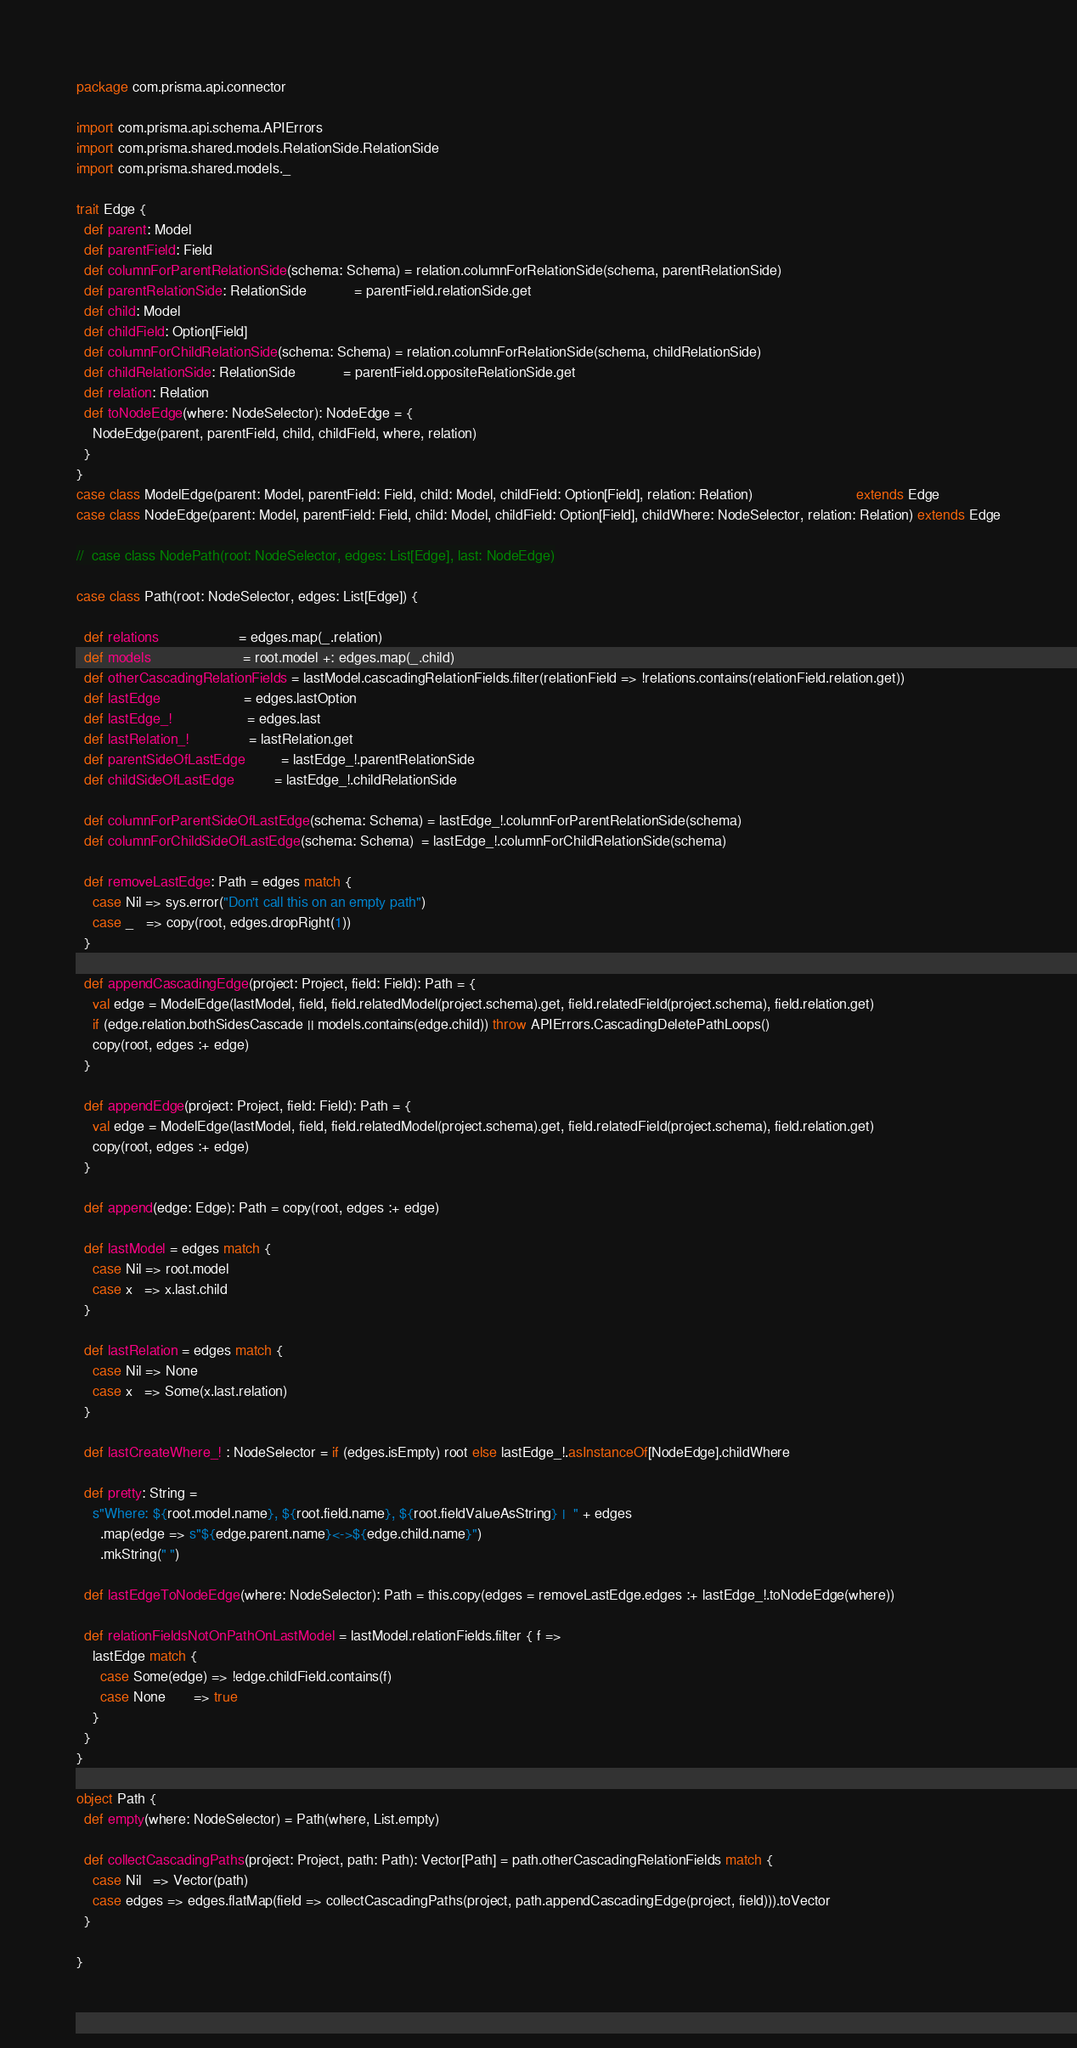Convert code to text. <code><loc_0><loc_0><loc_500><loc_500><_Scala_>package com.prisma.api.connector

import com.prisma.api.schema.APIErrors
import com.prisma.shared.models.RelationSide.RelationSide
import com.prisma.shared.models._

trait Edge {
  def parent: Model
  def parentField: Field
  def columnForParentRelationSide(schema: Schema) = relation.columnForRelationSide(schema, parentRelationSide)
  def parentRelationSide: RelationSide            = parentField.relationSide.get
  def child: Model
  def childField: Option[Field]
  def columnForChildRelationSide(schema: Schema) = relation.columnForRelationSide(schema, childRelationSide)
  def childRelationSide: RelationSide            = parentField.oppositeRelationSide.get
  def relation: Relation
  def toNodeEdge(where: NodeSelector): NodeEdge = {
    NodeEdge(parent, parentField, child, childField, where, relation)
  }
}
case class ModelEdge(parent: Model, parentField: Field, child: Model, childField: Option[Field], relation: Relation)                          extends Edge
case class NodeEdge(parent: Model, parentField: Field, child: Model, childField: Option[Field], childWhere: NodeSelector, relation: Relation) extends Edge

//  case class NodePath(root: NodeSelector, edges: List[Edge], last: NodeEdge)

case class Path(root: NodeSelector, edges: List[Edge]) {

  def relations                    = edges.map(_.relation)
  def models                       = root.model +: edges.map(_.child)
  def otherCascadingRelationFields = lastModel.cascadingRelationFields.filter(relationField => !relations.contains(relationField.relation.get))
  def lastEdge                     = edges.lastOption
  def lastEdge_!                   = edges.last
  def lastRelation_!               = lastRelation.get
  def parentSideOfLastEdge         = lastEdge_!.parentRelationSide
  def childSideOfLastEdge          = lastEdge_!.childRelationSide

  def columnForParentSideOfLastEdge(schema: Schema) = lastEdge_!.columnForParentRelationSide(schema)
  def columnForChildSideOfLastEdge(schema: Schema)  = lastEdge_!.columnForChildRelationSide(schema)

  def removeLastEdge: Path = edges match {
    case Nil => sys.error("Don't call this on an empty path")
    case _   => copy(root, edges.dropRight(1))
  }

  def appendCascadingEdge(project: Project, field: Field): Path = {
    val edge = ModelEdge(lastModel, field, field.relatedModel(project.schema).get, field.relatedField(project.schema), field.relation.get)
    if (edge.relation.bothSidesCascade || models.contains(edge.child)) throw APIErrors.CascadingDeletePathLoops()
    copy(root, edges :+ edge)
  }

  def appendEdge(project: Project, field: Field): Path = {
    val edge = ModelEdge(lastModel, field, field.relatedModel(project.schema).get, field.relatedField(project.schema), field.relation.get)
    copy(root, edges :+ edge)
  }

  def append(edge: Edge): Path = copy(root, edges :+ edge)

  def lastModel = edges match {
    case Nil => root.model
    case x   => x.last.child
  }

  def lastRelation = edges match {
    case Nil => None
    case x   => Some(x.last.relation)
  }

  def lastCreateWhere_! : NodeSelector = if (edges.isEmpty) root else lastEdge_!.asInstanceOf[NodeEdge].childWhere

  def pretty: String =
    s"Where: ${root.model.name}, ${root.field.name}, ${root.fieldValueAsString} |  " + edges
      .map(edge => s"${edge.parent.name}<->${edge.child.name}")
      .mkString(" ")

  def lastEdgeToNodeEdge(where: NodeSelector): Path = this.copy(edges = removeLastEdge.edges :+ lastEdge_!.toNodeEdge(where))

  def relationFieldsNotOnPathOnLastModel = lastModel.relationFields.filter { f =>
    lastEdge match {
      case Some(edge) => !edge.childField.contains(f)
      case None       => true
    }
  }
}

object Path {
  def empty(where: NodeSelector) = Path(where, List.empty)

  def collectCascadingPaths(project: Project, path: Path): Vector[Path] = path.otherCascadingRelationFields match {
    case Nil   => Vector(path)
    case edges => edges.flatMap(field => collectCascadingPaths(project, path.appendCascadingEdge(project, field))).toVector
  }

}
</code> 